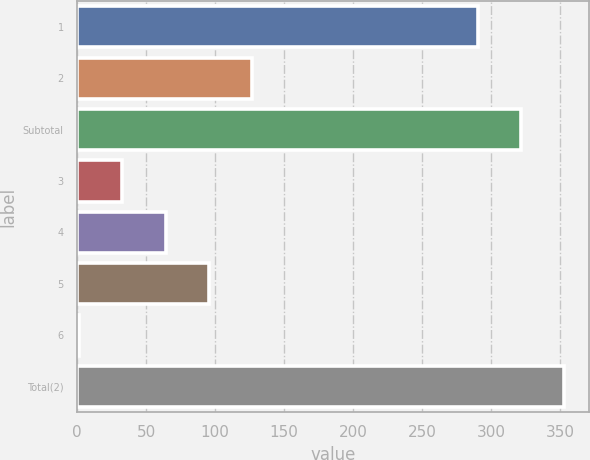Convert chart to OTSL. <chart><loc_0><loc_0><loc_500><loc_500><bar_chart><fcel>1<fcel>2<fcel>Subtotal<fcel>3<fcel>4<fcel>5<fcel>6<fcel>Total(2)<nl><fcel>290<fcel>126.82<fcel>321.37<fcel>32.71<fcel>64.08<fcel>95.45<fcel>1.34<fcel>352.74<nl></chart> 